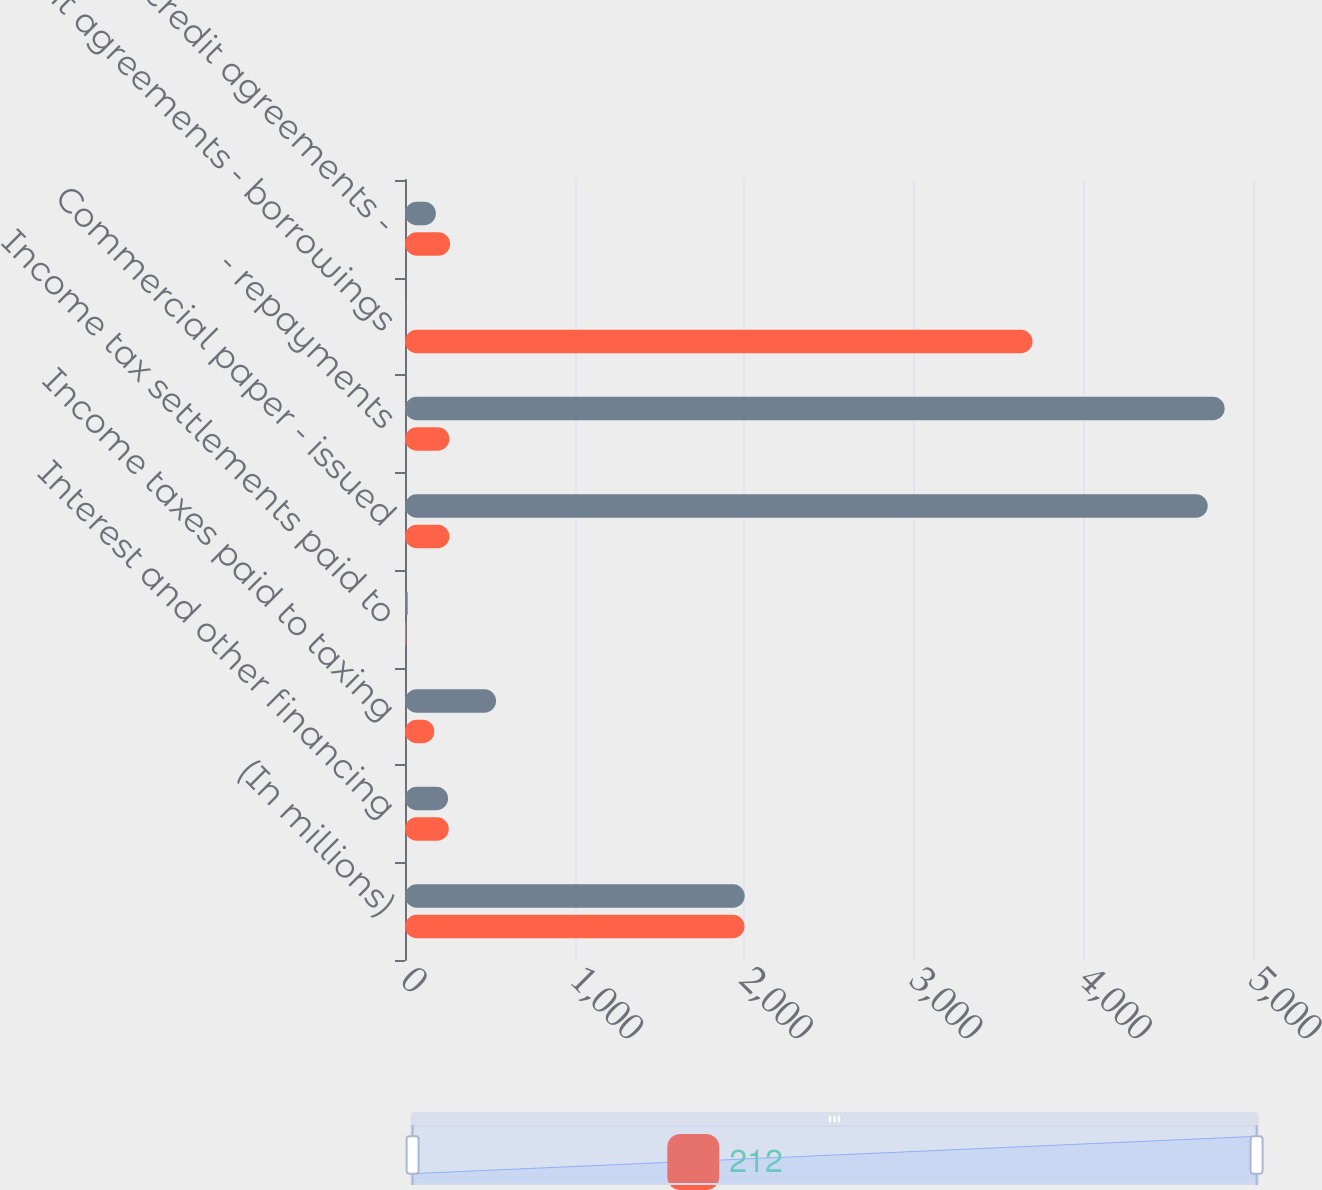<chart> <loc_0><loc_0><loc_500><loc_500><stacked_bar_chart><ecel><fcel>(In millions)<fcel>Interest and other financing<fcel>Income taxes paid to taxing<fcel>Income tax settlements paid to<fcel>Commercial paper - issued<fcel>- repayments<fcel>Credit agreements - borrowings<fcel>Ashland credit agreements -<nl><fcel>nan<fcel>2003<fcel>254<fcel>537<fcel>16<fcel>4733<fcel>4833<fcel>3<fcel>182<nl><fcel>212<fcel>2002<fcel>258<fcel>173<fcel>7<fcel>262<fcel>262<fcel>3700<fcel>266<nl></chart> 